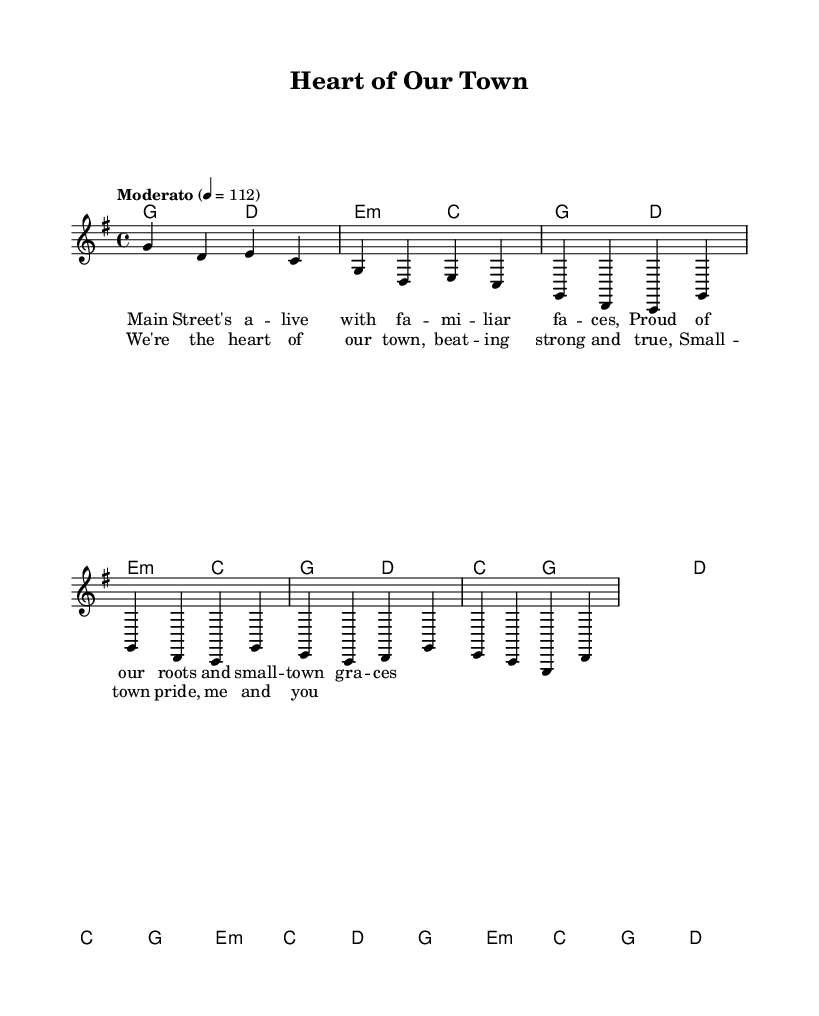What is the key signature of this music? The key signature is G major, indicated by one sharp (F#) to the left of the staff.
Answer: G major What is the time signature of this music? The time signature is 4/4, shown at the beginning of the score with two numbers stacked directly over each other.
Answer: 4/4 What is the tempo marking? The tempo marking is "Moderato," with a specific quarter note speed indicated as 112 beats per minute.
Answer: Moderato How many measures are there in the Chorus section? The Chorus section contains four measures, identified by counting the vertical lines that create divisions on the staff.
Answer: 4 Which chord is played with the first note of the Bridge? The first note of the Bridge is associated with the E minor chord, as shown in the harmonies below the melody staff.
Answer: E minor What is the lyrical theme focused on in this song? The lyrical theme focuses on small-town pride and community, as expressed through phrases referencing Main Street and local roots.
Answer: Small-town pride How many lyric lines are present in the first verse? There are two lyric lines present in the first verse, indicated by two separate lines of text under the melody.
Answer: 2 